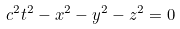Convert formula to latex. <formula><loc_0><loc_0><loc_500><loc_500>c ^ { 2 } t ^ { 2 } - x ^ { 2 } - y ^ { 2 } - z ^ { 2 } = 0</formula> 